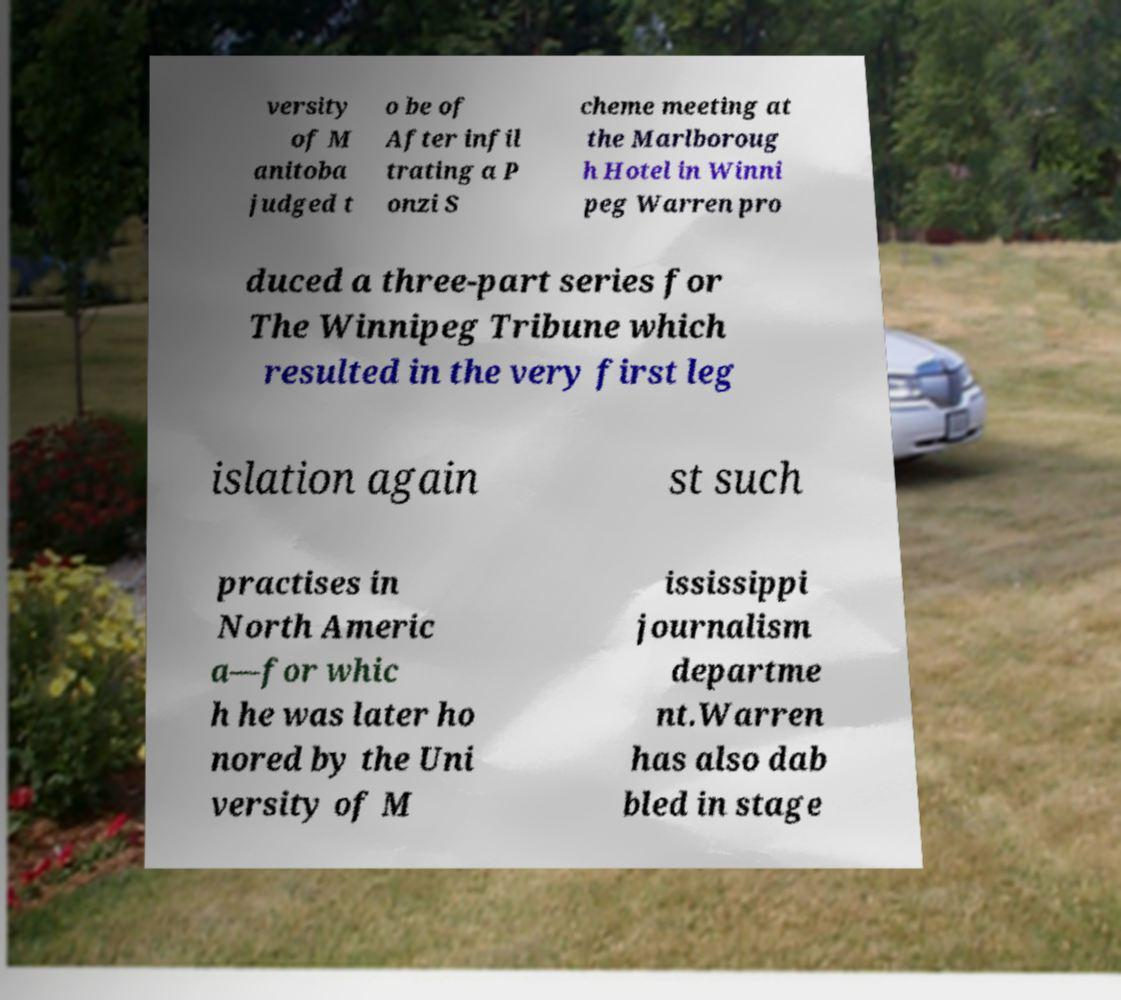What messages or text are displayed in this image? I need them in a readable, typed format. versity of M anitoba judged t o be of After infil trating a P onzi S cheme meeting at the Marlboroug h Hotel in Winni peg Warren pro duced a three-part series for The Winnipeg Tribune which resulted in the very first leg islation again st such practises in North Americ a—for whic h he was later ho nored by the Uni versity of M ississippi journalism departme nt.Warren has also dab bled in stage 